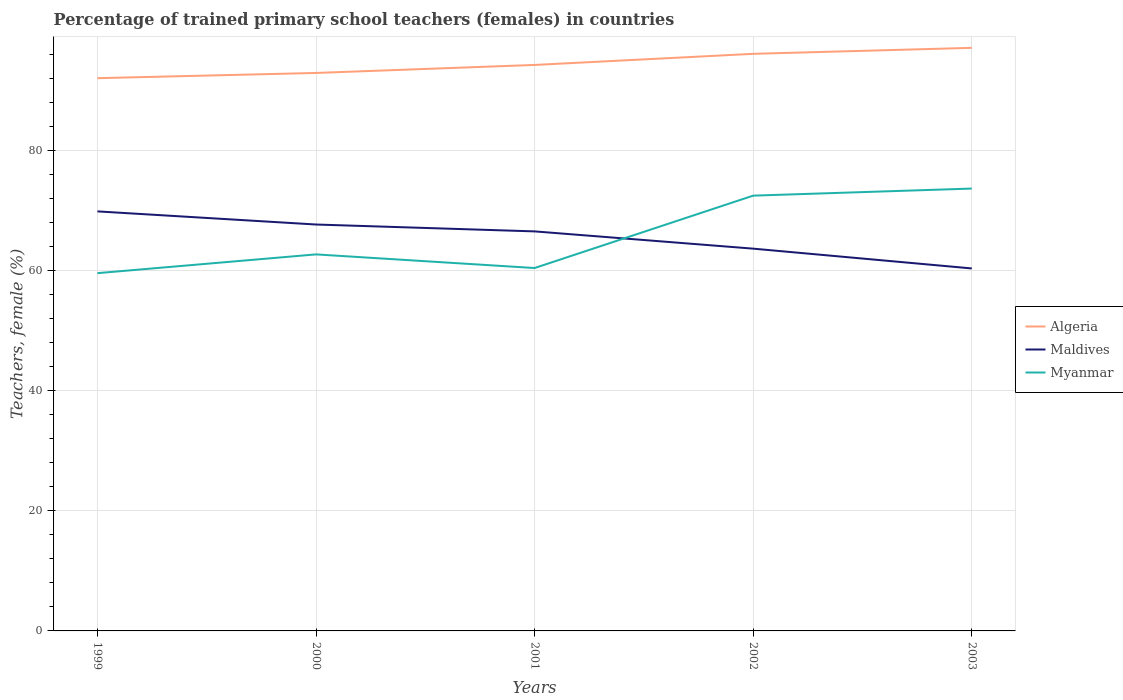How many different coloured lines are there?
Provide a short and direct response. 3. Does the line corresponding to Maldives intersect with the line corresponding to Myanmar?
Your response must be concise. Yes. Across all years, what is the maximum percentage of trained primary school teachers (females) in Myanmar?
Keep it short and to the point. 59.58. In which year was the percentage of trained primary school teachers (females) in Myanmar maximum?
Your answer should be compact. 1999. What is the total percentage of trained primary school teachers (females) in Maldives in the graph?
Offer a very short reply. 9.5. What is the difference between the highest and the second highest percentage of trained primary school teachers (females) in Maldives?
Offer a terse response. 9.5. What is the difference between the highest and the lowest percentage of trained primary school teachers (females) in Algeria?
Your answer should be compact. 2. Is the percentage of trained primary school teachers (females) in Myanmar strictly greater than the percentage of trained primary school teachers (females) in Maldives over the years?
Ensure brevity in your answer.  No. How many lines are there?
Your response must be concise. 3. How many years are there in the graph?
Offer a terse response. 5. What is the difference between two consecutive major ticks on the Y-axis?
Provide a short and direct response. 20. Does the graph contain grids?
Offer a very short reply. Yes. What is the title of the graph?
Make the answer very short. Percentage of trained primary school teachers (females) in countries. What is the label or title of the X-axis?
Provide a succinct answer. Years. What is the label or title of the Y-axis?
Your answer should be very brief. Teachers, female (%). What is the Teachers, female (%) of Algeria in 1999?
Your answer should be compact. 92.05. What is the Teachers, female (%) in Maldives in 1999?
Give a very brief answer. 69.86. What is the Teachers, female (%) of Myanmar in 1999?
Offer a terse response. 59.58. What is the Teachers, female (%) in Algeria in 2000?
Your answer should be compact. 92.91. What is the Teachers, female (%) of Maldives in 2000?
Give a very brief answer. 67.68. What is the Teachers, female (%) of Myanmar in 2000?
Offer a very short reply. 62.7. What is the Teachers, female (%) of Algeria in 2001?
Offer a very short reply. 94.25. What is the Teachers, female (%) in Maldives in 2001?
Your answer should be very brief. 66.53. What is the Teachers, female (%) in Myanmar in 2001?
Give a very brief answer. 60.43. What is the Teachers, female (%) in Algeria in 2002?
Provide a short and direct response. 96.1. What is the Teachers, female (%) of Maldives in 2002?
Provide a short and direct response. 63.66. What is the Teachers, female (%) of Myanmar in 2002?
Provide a short and direct response. 72.48. What is the Teachers, female (%) of Algeria in 2003?
Offer a very short reply. 97.1. What is the Teachers, female (%) in Maldives in 2003?
Provide a succinct answer. 60.36. What is the Teachers, female (%) in Myanmar in 2003?
Your response must be concise. 73.66. Across all years, what is the maximum Teachers, female (%) in Algeria?
Your answer should be compact. 97.1. Across all years, what is the maximum Teachers, female (%) in Maldives?
Offer a terse response. 69.86. Across all years, what is the maximum Teachers, female (%) of Myanmar?
Your answer should be very brief. 73.66. Across all years, what is the minimum Teachers, female (%) in Algeria?
Offer a very short reply. 92.05. Across all years, what is the minimum Teachers, female (%) in Maldives?
Your answer should be compact. 60.36. Across all years, what is the minimum Teachers, female (%) in Myanmar?
Offer a very short reply. 59.58. What is the total Teachers, female (%) of Algeria in the graph?
Your response must be concise. 472.4. What is the total Teachers, female (%) of Maldives in the graph?
Offer a very short reply. 328.09. What is the total Teachers, female (%) in Myanmar in the graph?
Offer a terse response. 328.86. What is the difference between the Teachers, female (%) of Algeria in 1999 and that in 2000?
Provide a short and direct response. -0.87. What is the difference between the Teachers, female (%) of Maldives in 1999 and that in 2000?
Your answer should be very brief. 2.19. What is the difference between the Teachers, female (%) in Myanmar in 1999 and that in 2000?
Your answer should be very brief. -3.13. What is the difference between the Teachers, female (%) of Algeria in 1999 and that in 2001?
Provide a short and direct response. -2.2. What is the difference between the Teachers, female (%) of Maldives in 1999 and that in 2001?
Make the answer very short. 3.33. What is the difference between the Teachers, female (%) of Myanmar in 1999 and that in 2001?
Ensure brevity in your answer.  -0.85. What is the difference between the Teachers, female (%) in Algeria in 1999 and that in 2002?
Your response must be concise. -4.05. What is the difference between the Teachers, female (%) in Maldives in 1999 and that in 2002?
Your response must be concise. 6.2. What is the difference between the Teachers, female (%) of Myanmar in 1999 and that in 2002?
Keep it short and to the point. -12.91. What is the difference between the Teachers, female (%) of Algeria in 1999 and that in 2003?
Offer a very short reply. -5.05. What is the difference between the Teachers, female (%) of Maldives in 1999 and that in 2003?
Your answer should be compact. 9.5. What is the difference between the Teachers, female (%) of Myanmar in 1999 and that in 2003?
Your answer should be very brief. -14.09. What is the difference between the Teachers, female (%) of Algeria in 2000 and that in 2001?
Offer a very short reply. -1.34. What is the difference between the Teachers, female (%) of Maldives in 2000 and that in 2001?
Offer a terse response. 1.14. What is the difference between the Teachers, female (%) of Myanmar in 2000 and that in 2001?
Offer a terse response. 2.27. What is the difference between the Teachers, female (%) in Algeria in 2000 and that in 2002?
Your answer should be very brief. -3.18. What is the difference between the Teachers, female (%) of Maldives in 2000 and that in 2002?
Give a very brief answer. 4.02. What is the difference between the Teachers, female (%) in Myanmar in 2000 and that in 2002?
Make the answer very short. -9.78. What is the difference between the Teachers, female (%) of Algeria in 2000 and that in 2003?
Give a very brief answer. -4.18. What is the difference between the Teachers, female (%) of Maldives in 2000 and that in 2003?
Offer a terse response. 7.32. What is the difference between the Teachers, female (%) of Myanmar in 2000 and that in 2003?
Provide a succinct answer. -10.96. What is the difference between the Teachers, female (%) of Algeria in 2001 and that in 2002?
Ensure brevity in your answer.  -1.85. What is the difference between the Teachers, female (%) in Maldives in 2001 and that in 2002?
Give a very brief answer. 2.87. What is the difference between the Teachers, female (%) in Myanmar in 2001 and that in 2002?
Make the answer very short. -12.05. What is the difference between the Teachers, female (%) of Algeria in 2001 and that in 2003?
Your answer should be very brief. -2.85. What is the difference between the Teachers, female (%) of Maldives in 2001 and that in 2003?
Offer a very short reply. 6.17. What is the difference between the Teachers, female (%) of Myanmar in 2001 and that in 2003?
Give a very brief answer. -13.23. What is the difference between the Teachers, female (%) of Algeria in 2002 and that in 2003?
Give a very brief answer. -1. What is the difference between the Teachers, female (%) in Maldives in 2002 and that in 2003?
Provide a short and direct response. 3.3. What is the difference between the Teachers, female (%) of Myanmar in 2002 and that in 2003?
Ensure brevity in your answer.  -1.18. What is the difference between the Teachers, female (%) in Algeria in 1999 and the Teachers, female (%) in Maldives in 2000?
Your answer should be compact. 24.37. What is the difference between the Teachers, female (%) in Algeria in 1999 and the Teachers, female (%) in Myanmar in 2000?
Your answer should be compact. 29.34. What is the difference between the Teachers, female (%) of Maldives in 1999 and the Teachers, female (%) of Myanmar in 2000?
Keep it short and to the point. 7.16. What is the difference between the Teachers, female (%) in Algeria in 1999 and the Teachers, female (%) in Maldives in 2001?
Keep it short and to the point. 25.51. What is the difference between the Teachers, female (%) of Algeria in 1999 and the Teachers, female (%) of Myanmar in 2001?
Provide a succinct answer. 31.62. What is the difference between the Teachers, female (%) in Maldives in 1999 and the Teachers, female (%) in Myanmar in 2001?
Your response must be concise. 9.43. What is the difference between the Teachers, female (%) in Algeria in 1999 and the Teachers, female (%) in Maldives in 2002?
Your response must be concise. 28.39. What is the difference between the Teachers, female (%) of Algeria in 1999 and the Teachers, female (%) of Myanmar in 2002?
Your response must be concise. 19.56. What is the difference between the Teachers, female (%) of Maldives in 1999 and the Teachers, female (%) of Myanmar in 2002?
Keep it short and to the point. -2.62. What is the difference between the Teachers, female (%) in Algeria in 1999 and the Teachers, female (%) in Maldives in 2003?
Ensure brevity in your answer.  31.68. What is the difference between the Teachers, female (%) of Algeria in 1999 and the Teachers, female (%) of Myanmar in 2003?
Your response must be concise. 18.38. What is the difference between the Teachers, female (%) in Maldives in 1999 and the Teachers, female (%) in Myanmar in 2003?
Make the answer very short. -3.8. What is the difference between the Teachers, female (%) in Algeria in 2000 and the Teachers, female (%) in Maldives in 2001?
Make the answer very short. 26.38. What is the difference between the Teachers, female (%) of Algeria in 2000 and the Teachers, female (%) of Myanmar in 2001?
Your response must be concise. 32.48. What is the difference between the Teachers, female (%) of Maldives in 2000 and the Teachers, female (%) of Myanmar in 2001?
Keep it short and to the point. 7.25. What is the difference between the Teachers, female (%) of Algeria in 2000 and the Teachers, female (%) of Maldives in 2002?
Ensure brevity in your answer.  29.26. What is the difference between the Teachers, female (%) of Algeria in 2000 and the Teachers, female (%) of Myanmar in 2002?
Make the answer very short. 20.43. What is the difference between the Teachers, female (%) of Maldives in 2000 and the Teachers, female (%) of Myanmar in 2002?
Your response must be concise. -4.81. What is the difference between the Teachers, female (%) in Algeria in 2000 and the Teachers, female (%) in Maldives in 2003?
Ensure brevity in your answer.  32.55. What is the difference between the Teachers, female (%) in Algeria in 2000 and the Teachers, female (%) in Myanmar in 2003?
Give a very brief answer. 19.25. What is the difference between the Teachers, female (%) in Maldives in 2000 and the Teachers, female (%) in Myanmar in 2003?
Your answer should be compact. -5.99. What is the difference between the Teachers, female (%) of Algeria in 2001 and the Teachers, female (%) of Maldives in 2002?
Your answer should be very brief. 30.59. What is the difference between the Teachers, female (%) in Algeria in 2001 and the Teachers, female (%) in Myanmar in 2002?
Offer a terse response. 21.77. What is the difference between the Teachers, female (%) in Maldives in 2001 and the Teachers, female (%) in Myanmar in 2002?
Make the answer very short. -5.95. What is the difference between the Teachers, female (%) of Algeria in 2001 and the Teachers, female (%) of Maldives in 2003?
Ensure brevity in your answer.  33.89. What is the difference between the Teachers, female (%) of Algeria in 2001 and the Teachers, female (%) of Myanmar in 2003?
Keep it short and to the point. 20.59. What is the difference between the Teachers, female (%) in Maldives in 2001 and the Teachers, female (%) in Myanmar in 2003?
Ensure brevity in your answer.  -7.13. What is the difference between the Teachers, female (%) of Algeria in 2002 and the Teachers, female (%) of Maldives in 2003?
Your response must be concise. 35.74. What is the difference between the Teachers, female (%) in Algeria in 2002 and the Teachers, female (%) in Myanmar in 2003?
Keep it short and to the point. 22.43. What is the difference between the Teachers, female (%) of Maldives in 2002 and the Teachers, female (%) of Myanmar in 2003?
Make the answer very short. -10.01. What is the average Teachers, female (%) of Algeria per year?
Keep it short and to the point. 94.48. What is the average Teachers, female (%) in Maldives per year?
Provide a short and direct response. 65.62. What is the average Teachers, female (%) of Myanmar per year?
Provide a short and direct response. 65.77. In the year 1999, what is the difference between the Teachers, female (%) of Algeria and Teachers, female (%) of Maldives?
Make the answer very short. 22.18. In the year 1999, what is the difference between the Teachers, female (%) of Algeria and Teachers, female (%) of Myanmar?
Offer a very short reply. 32.47. In the year 1999, what is the difference between the Teachers, female (%) of Maldives and Teachers, female (%) of Myanmar?
Provide a succinct answer. 10.29. In the year 2000, what is the difference between the Teachers, female (%) of Algeria and Teachers, female (%) of Maldives?
Provide a short and direct response. 25.24. In the year 2000, what is the difference between the Teachers, female (%) of Algeria and Teachers, female (%) of Myanmar?
Ensure brevity in your answer.  30.21. In the year 2000, what is the difference between the Teachers, female (%) of Maldives and Teachers, female (%) of Myanmar?
Offer a terse response. 4.97. In the year 2001, what is the difference between the Teachers, female (%) of Algeria and Teachers, female (%) of Maldives?
Give a very brief answer. 27.72. In the year 2001, what is the difference between the Teachers, female (%) in Algeria and Teachers, female (%) in Myanmar?
Your answer should be compact. 33.82. In the year 2001, what is the difference between the Teachers, female (%) of Maldives and Teachers, female (%) of Myanmar?
Offer a terse response. 6.1. In the year 2002, what is the difference between the Teachers, female (%) of Algeria and Teachers, female (%) of Maldives?
Your answer should be compact. 32.44. In the year 2002, what is the difference between the Teachers, female (%) in Algeria and Teachers, female (%) in Myanmar?
Your answer should be compact. 23.61. In the year 2002, what is the difference between the Teachers, female (%) in Maldives and Teachers, female (%) in Myanmar?
Make the answer very short. -8.83. In the year 2003, what is the difference between the Teachers, female (%) of Algeria and Teachers, female (%) of Maldives?
Your response must be concise. 36.73. In the year 2003, what is the difference between the Teachers, female (%) in Algeria and Teachers, female (%) in Myanmar?
Keep it short and to the point. 23.43. In the year 2003, what is the difference between the Teachers, female (%) in Maldives and Teachers, female (%) in Myanmar?
Provide a short and direct response. -13.3. What is the ratio of the Teachers, female (%) in Maldives in 1999 to that in 2000?
Provide a short and direct response. 1.03. What is the ratio of the Teachers, female (%) of Myanmar in 1999 to that in 2000?
Provide a short and direct response. 0.95. What is the ratio of the Teachers, female (%) of Algeria in 1999 to that in 2001?
Keep it short and to the point. 0.98. What is the ratio of the Teachers, female (%) of Maldives in 1999 to that in 2001?
Keep it short and to the point. 1.05. What is the ratio of the Teachers, female (%) in Myanmar in 1999 to that in 2001?
Provide a short and direct response. 0.99. What is the ratio of the Teachers, female (%) in Algeria in 1999 to that in 2002?
Your answer should be very brief. 0.96. What is the ratio of the Teachers, female (%) of Maldives in 1999 to that in 2002?
Provide a succinct answer. 1.1. What is the ratio of the Teachers, female (%) in Myanmar in 1999 to that in 2002?
Provide a succinct answer. 0.82. What is the ratio of the Teachers, female (%) in Algeria in 1999 to that in 2003?
Make the answer very short. 0.95. What is the ratio of the Teachers, female (%) of Maldives in 1999 to that in 2003?
Offer a terse response. 1.16. What is the ratio of the Teachers, female (%) of Myanmar in 1999 to that in 2003?
Keep it short and to the point. 0.81. What is the ratio of the Teachers, female (%) in Algeria in 2000 to that in 2001?
Provide a short and direct response. 0.99. What is the ratio of the Teachers, female (%) in Maldives in 2000 to that in 2001?
Offer a terse response. 1.02. What is the ratio of the Teachers, female (%) of Myanmar in 2000 to that in 2001?
Make the answer very short. 1.04. What is the ratio of the Teachers, female (%) in Algeria in 2000 to that in 2002?
Your answer should be compact. 0.97. What is the ratio of the Teachers, female (%) of Maldives in 2000 to that in 2002?
Your answer should be very brief. 1.06. What is the ratio of the Teachers, female (%) in Myanmar in 2000 to that in 2002?
Give a very brief answer. 0.86. What is the ratio of the Teachers, female (%) in Algeria in 2000 to that in 2003?
Your answer should be compact. 0.96. What is the ratio of the Teachers, female (%) of Maldives in 2000 to that in 2003?
Give a very brief answer. 1.12. What is the ratio of the Teachers, female (%) of Myanmar in 2000 to that in 2003?
Make the answer very short. 0.85. What is the ratio of the Teachers, female (%) in Algeria in 2001 to that in 2002?
Provide a short and direct response. 0.98. What is the ratio of the Teachers, female (%) of Maldives in 2001 to that in 2002?
Provide a short and direct response. 1.05. What is the ratio of the Teachers, female (%) in Myanmar in 2001 to that in 2002?
Keep it short and to the point. 0.83. What is the ratio of the Teachers, female (%) of Algeria in 2001 to that in 2003?
Your answer should be very brief. 0.97. What is the ratio of the Teachers, female (%) of Maldives in 2001 to that in 2003?
Give a very brief answer. 1.1. What is the ratio of the Teachers, female (%) in Myanmar in 2001 to that in 2003?
Your answer should be very brief. 0.82. What is the ratio of the Teachers, female (%) of Algeria in 2002 to that in 2003?
Offer a terse response. 0.99. What is the ratio of the Teachers, female (%) in Maldives in 2002 to that in 2003?
Your response must be concise. 1.05. What is the difference between the highest and the second highest Teachers, female (%) in Maldives?
Offer a very short reply. 2.19. What is the difference between the highest and the second highest Teachers, female (%) in Myanmar?
Make the answer very short. 1.18. What is the difference between the highest and the lowest Teachers, female (%) in Algeria?
Provide a short and direct response. 5.05. What is the difference between the highest and the lowest Teachers, female (%) of Maldives?
Your answer should be compact. 9.5. What is the difference between the highest and the lowest Teachers, female (%) of Myanmar?
Ensure brevity in your answer.  14.09. 